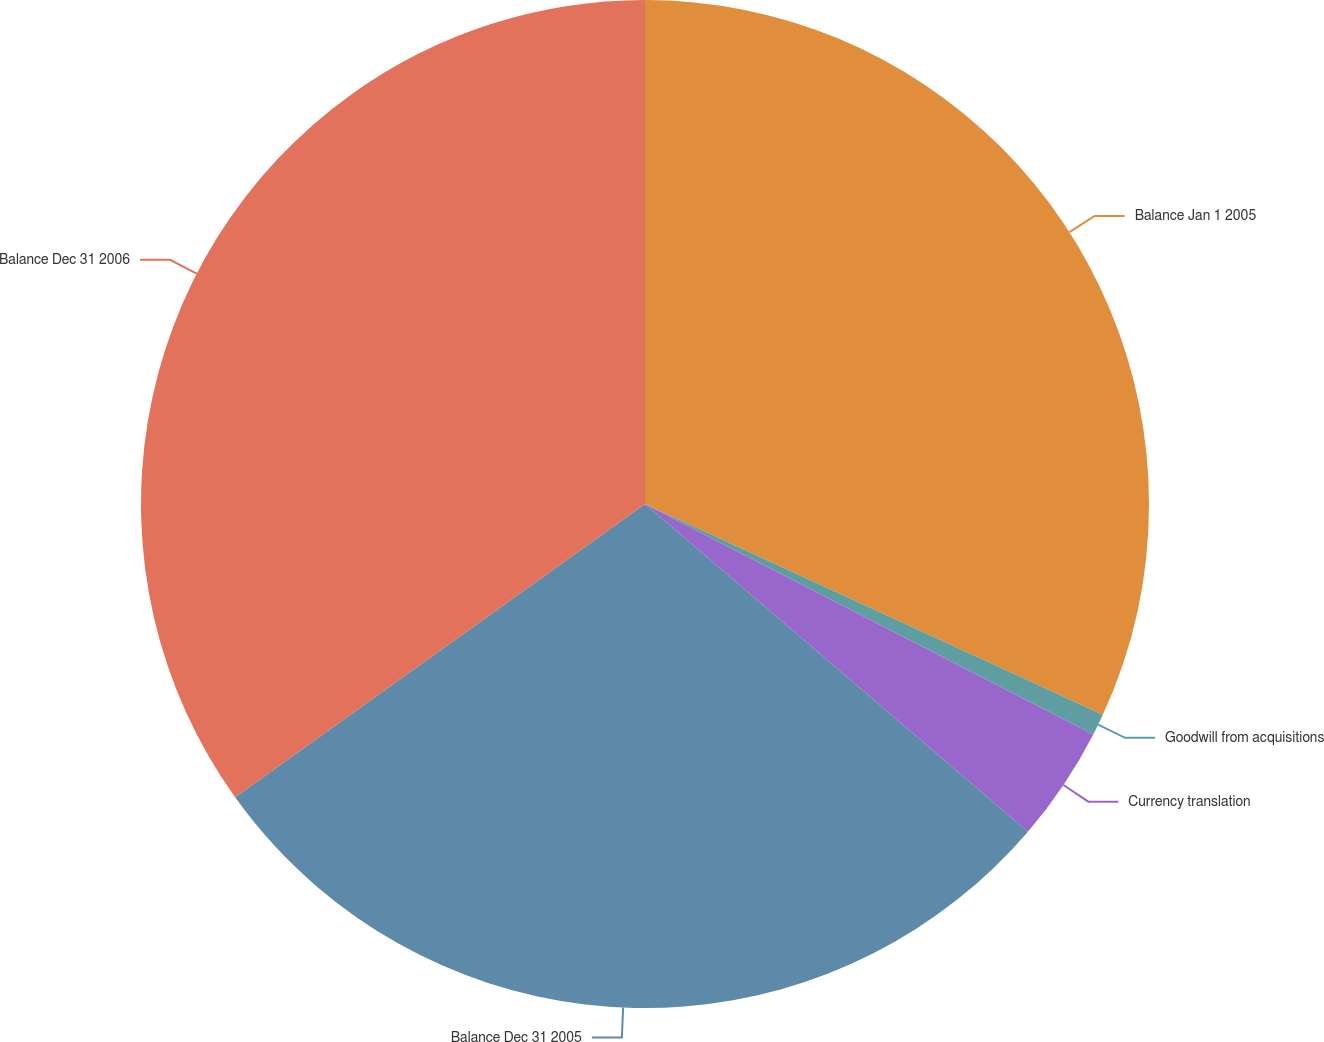<chart> <loc_0><loc_0><loc_500><loc_500><pie_chart><fcel>Balance Jan 1 2005<fcel>Goodwill from acquisitions<fcel>Currency translation<fcel>Balance Dec 31 2005<fcel>Balance Dec 31 2006<nl><fcel>31.87%<fcel>0.69%<fcel>3.71%<fcel>28.85%<fcel>34.89%<nl></chart> 